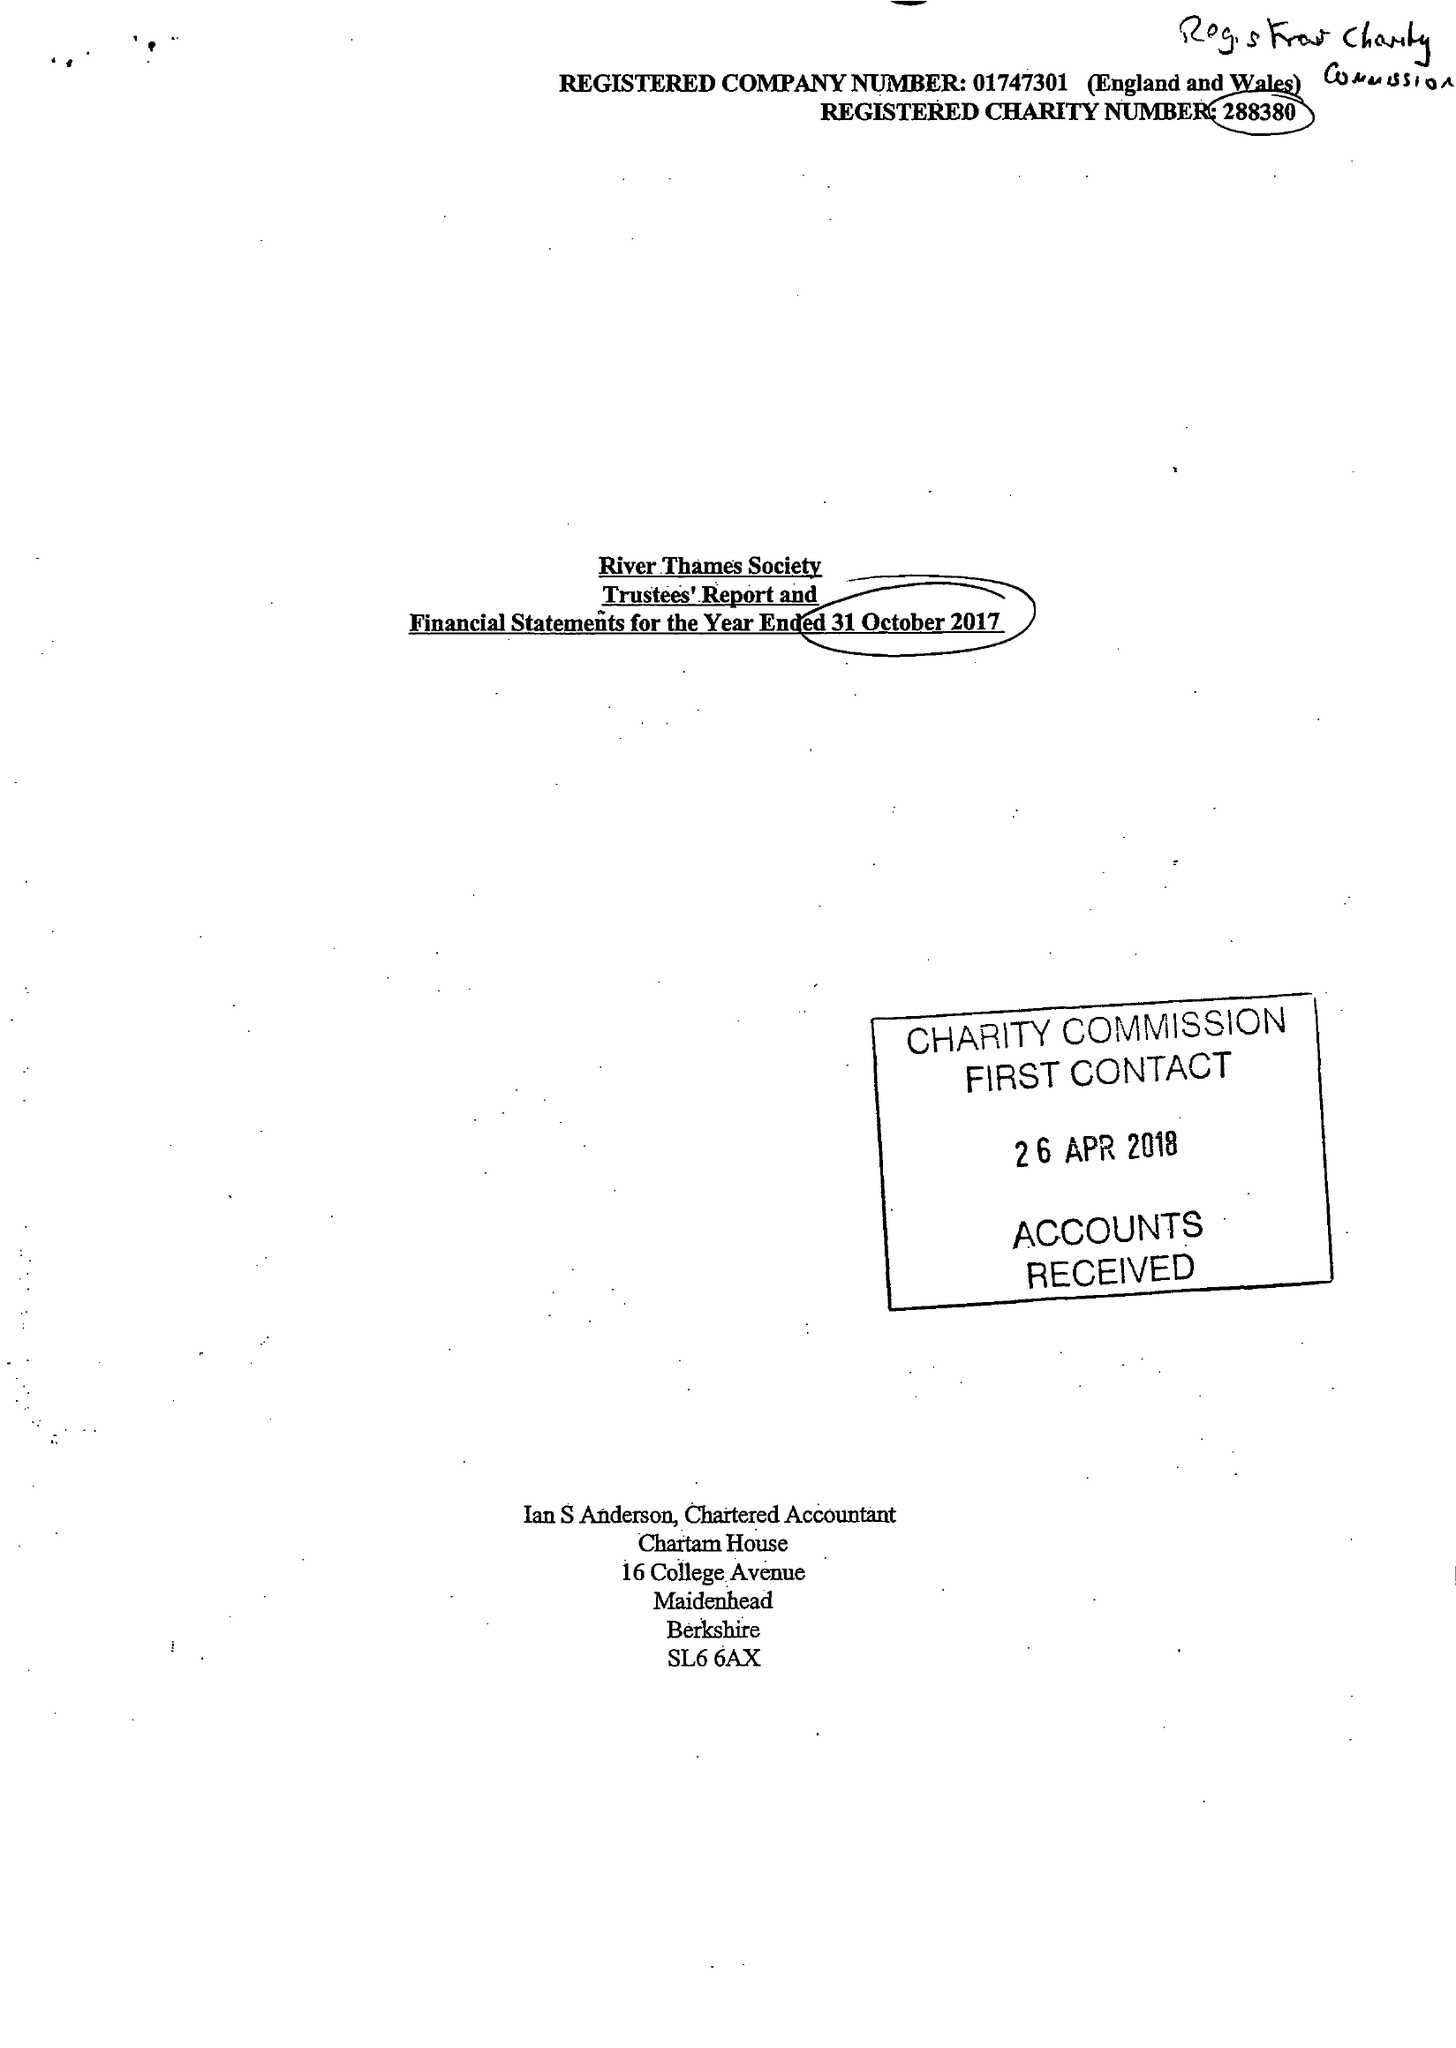What is the value for the address__postcode?
Answer the question using a single word or phrase. SL4 1JP 